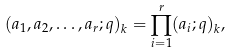<formula> <loc_0><loc_0><loc_500><loc_500>( a _ { 1 } , a _ { 2 } , \dots , a _ { r } ; q ) _ { k } = \prod _ { i = 1 } ^ { r } ( a _ { i } ; q ) _ { k } ,</formula> 